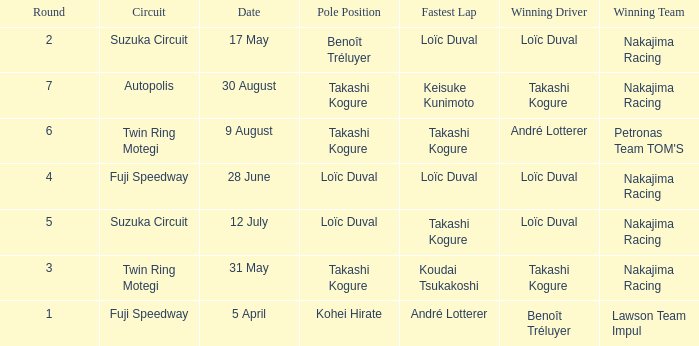What was the earlier round where Takashi Kogure got the fastest lap? 5.0. 